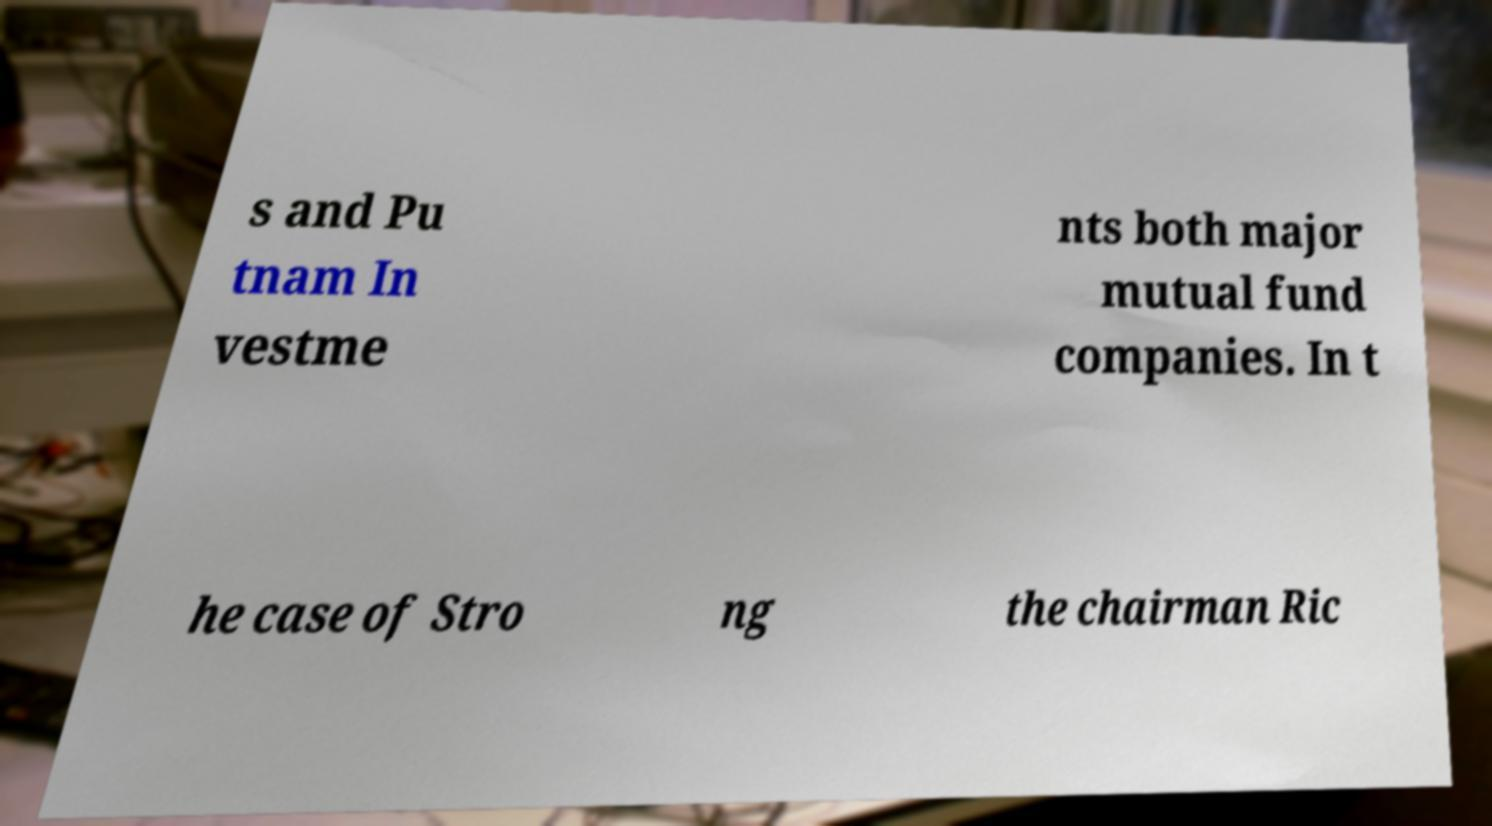Can you accurately transcribe the text from the provided image for me? s and Pu tnam In vestme nts both major mutual fund companies. In t he case of Stro ng the chairman Ric 